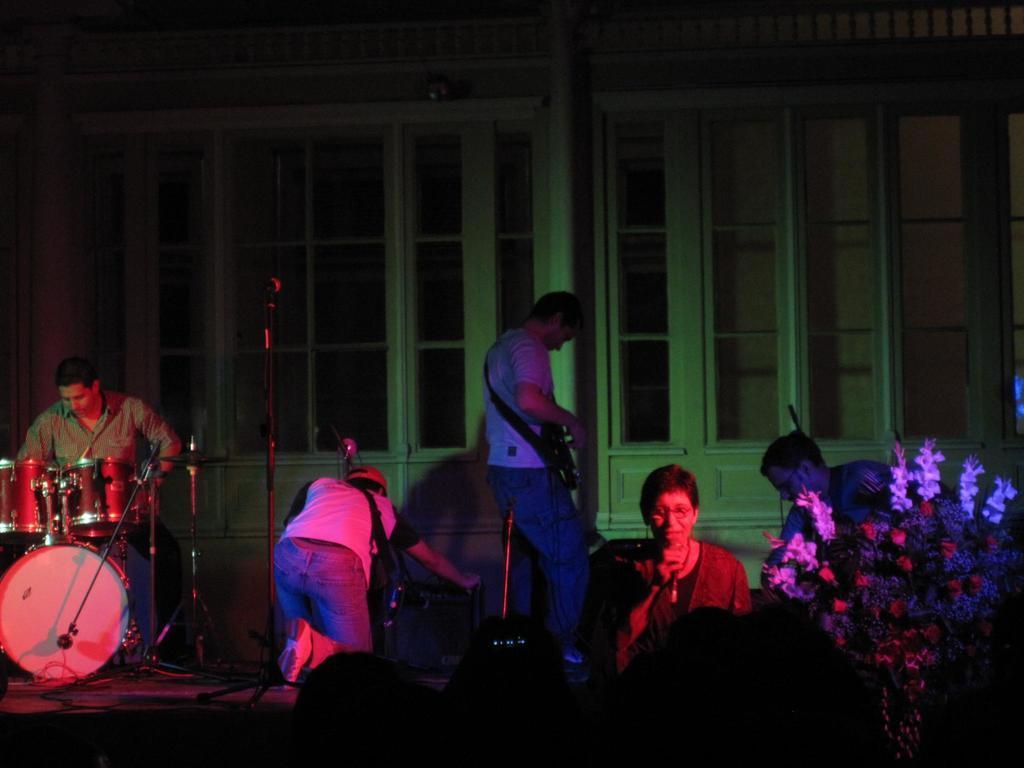Can you describe this image briefly? A man is beating the drums. In the middle a woman is singing a song on microphone. The right side there is a tree. 